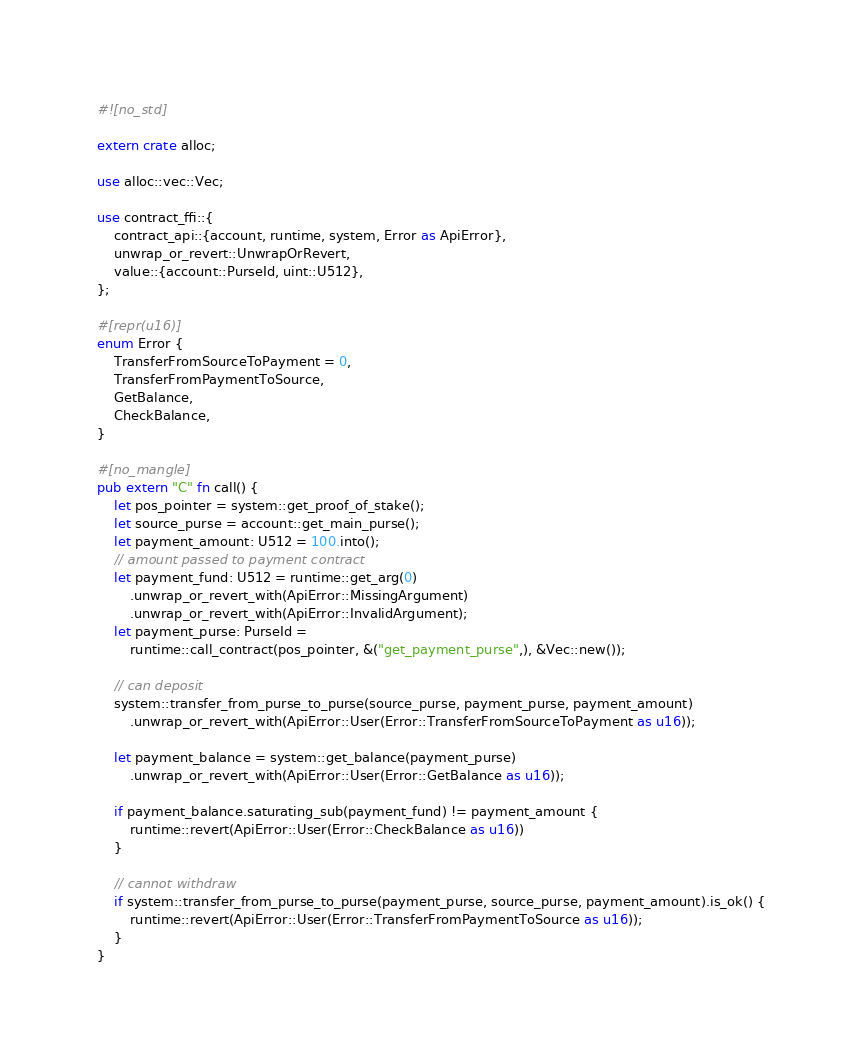Convert code to text. <code><loc_0><loc_0><loc_500><loc_500><_Rust_>#![no_std]

extern crate alloc;

use alloc::vec::Vec;

use contract_ffi::{
    contract_api::{account, runtime, system, Error as ApiError},
    unwrap_or_revert::UnwrapOrRevert,
    value::{account::PurseId, uint::U512},
};

#[repr(u16)]
enum Error {
    TransferFromSourceToPayment = 0,
    TransferFromPaymentToSource,
    GetBalance,
    CheckBalance,
}

#[no_mangle]
pub extern "C" fn call() {
    let pos_pointer = system::get_proof_of_stake();
    let source_purse = account::get_main_purse();
    let payment_amount: U512 = 100.into();
    // amount passed to payment contract
    let payment_fund: U512 = runtime::get_arg(0)
        .unwrap_or_revert_with(ApiError::MissingArgument)
        .unwrap_or_revert_with(ApiError::InvalidArgument);
    let payment_purse: PurseId =
        runtime::call_contract(pos_pointer, &("get_payment_purse",), &Vec::new());

    // can deposit
    system::transfer_from_purse_to_purse(source_purse, payment_purse, payment_amount)
        .unwrap_or_revert_with(ApiError::User(Error::TransferFromSourceToPayment as u16));

    let payment_balance = system::get_balance(payment_purse)
        .unwrap_or_revert_with(ApiError::User(Error::GetBalance as u16));

    if payment_balance.saturating_sub(payment_fund) != payment_amount {
        runtime::revert(ApiError::User(Error::CheckBalance as u16))
    }

    // cannot withdraw
    if system::transfer_from_purse_to_purse(payment_purse, source_purse, payment_amount).is_ok() {
        runtime::revert(ApiError::User(Error::TransferFromPaymentToSource as u16));
    }
}
</code> 